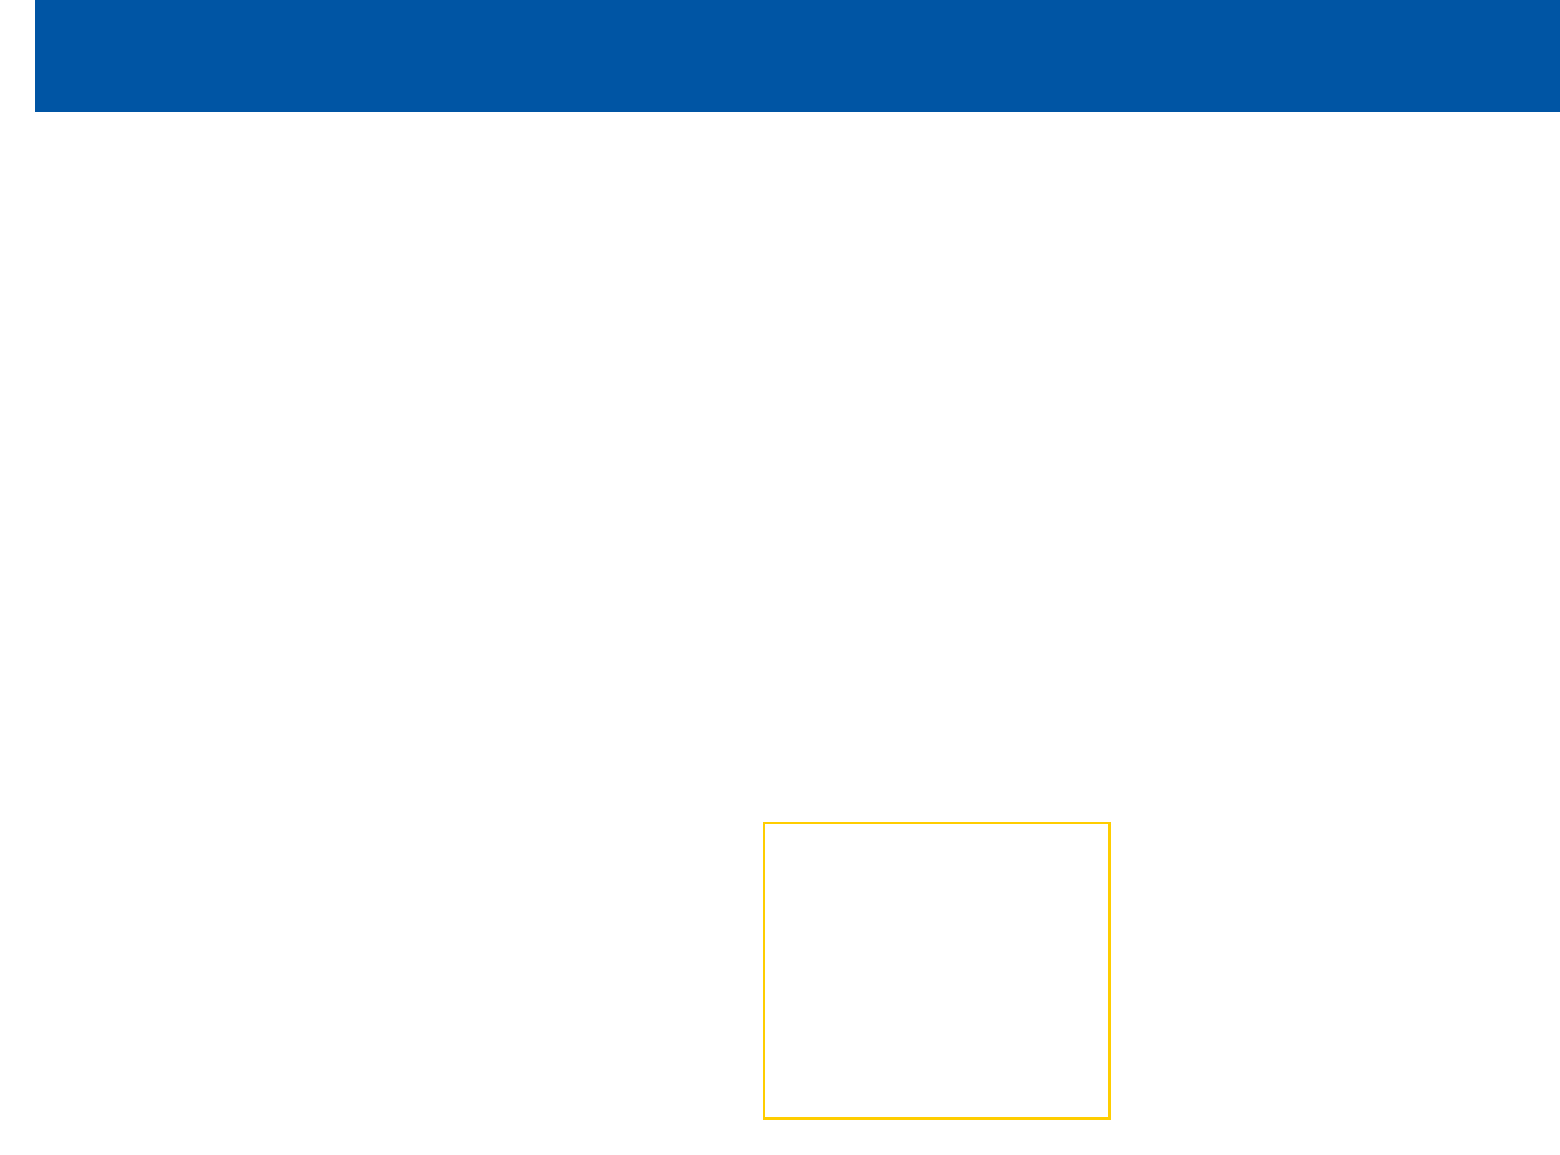What is the primary emphasis of La Rochelle's 2022-2023 season strategy? The main focus is on physical dominance and aggressive defense, as stated in the season strategy section.
Answer: Physical dominance and aggressive defense What position does Pierre Boudehent primarily play? The document states that Boudehent is primarily used as a wing or fullback.
Answer: Wing or fullback How many tries did Pierre Boudehent score against Toulouse in the Top 14? The specific performance against Toulouse indicates that Boudehent scored two tries.
Answer: Two tries What is one area for improvement for Pierre Boudehent? The document lists several areas for improvement, one being enhancing coordination with fly-half Antoine Hastoy.
Answer: Coordination with Antoine Hastoy What tactic is used to exploit Boudehent's aerial skills? The tactical adjustments mention increased use of cross-field kicks to take advantage of Boudehent's skills.
Answer: Cross-field kicks How does Pierre Boudehent contribute defensively? The document highlights that he is excellent under high balls, which is crucial for defensive positioning.
Answer: Excellent under high balls What type of play did La Rochelle improve this season? The document emphasizes improved set-piece play, particularly in scrums and lineouts.
Answer: Set-piece play What is one role of Pierre Boudehent in the team's counterattacking strategy? Boudehent is noted as a key contributor to La Rochelle's counterattacking strategy, indicating his importance in this area.
Answer: Key contributor to counterattacks How did Boudehent perform in the European Champions Cup against Leinster? The document notes that he had crucial defensive contributions in that match.
Answer: Crucial defensive contributions 